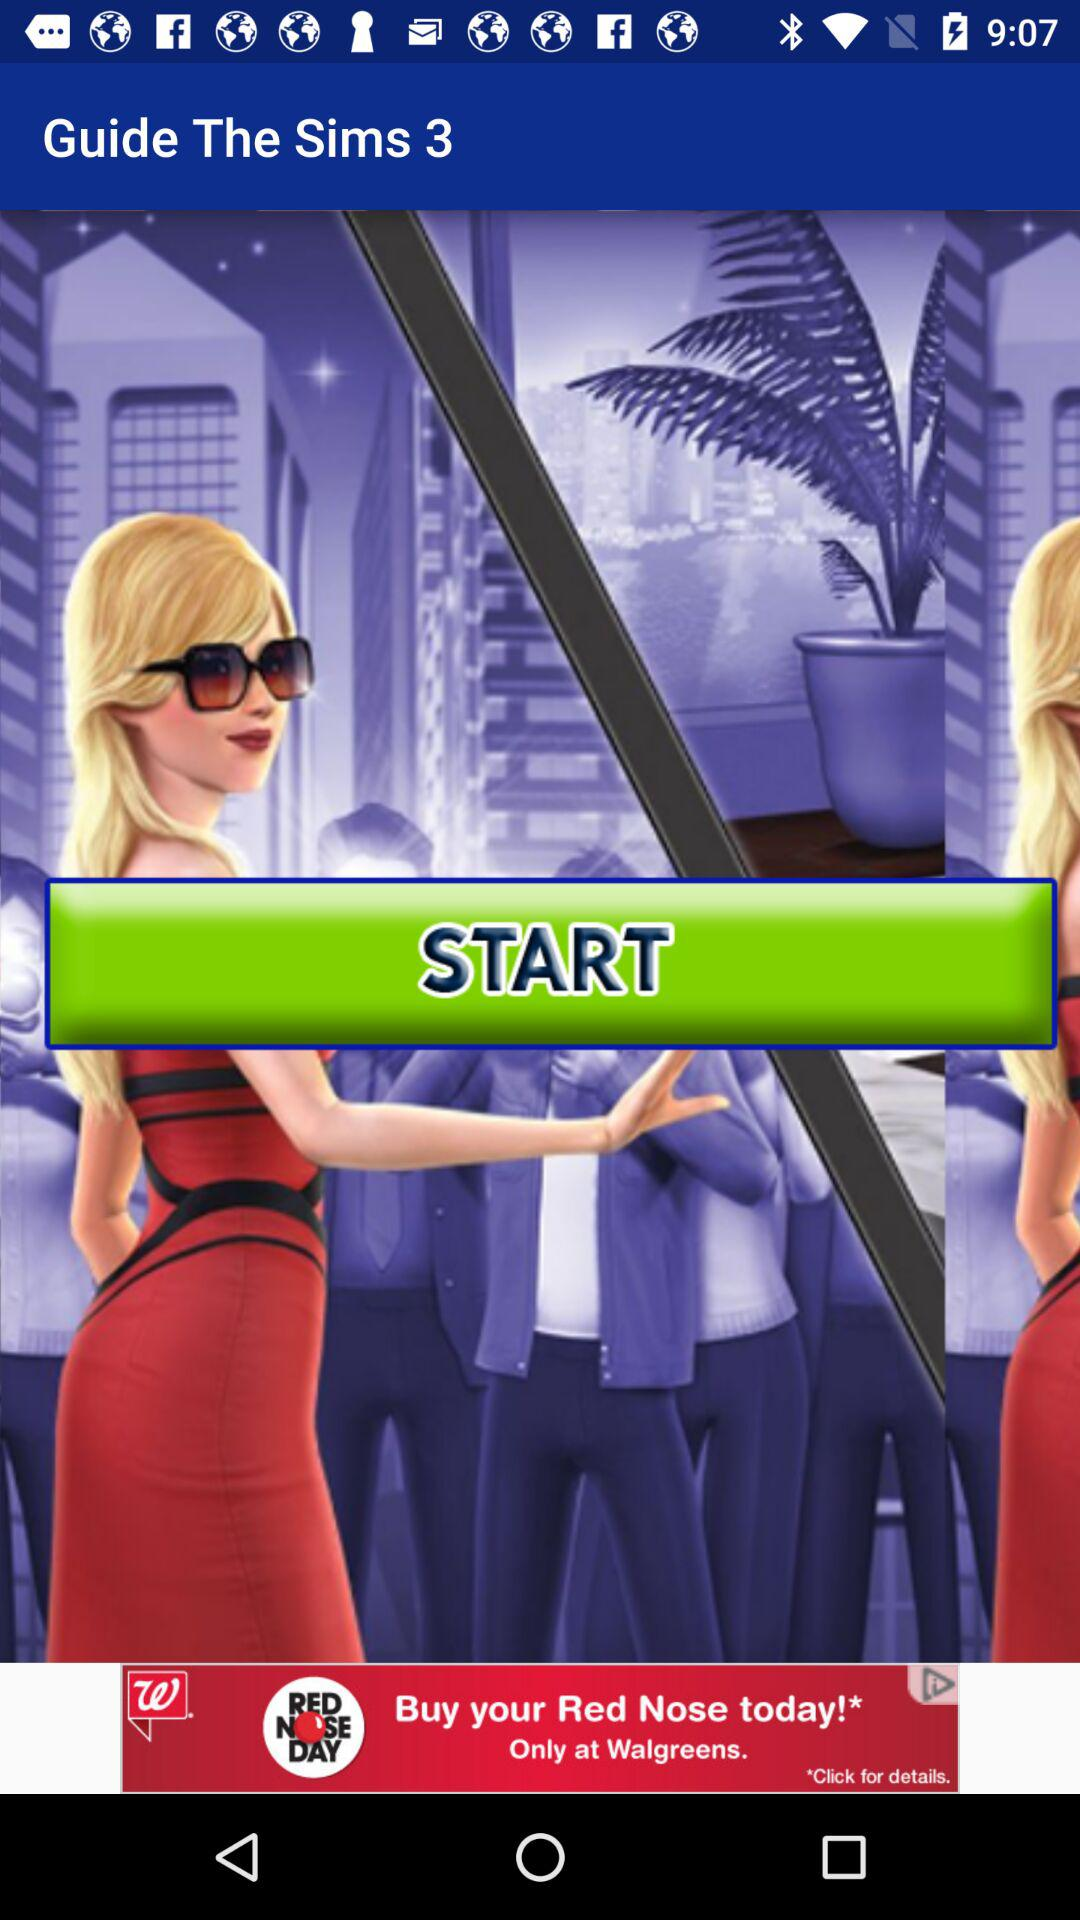What is the name of the application? The name of the application is "Guide The Sims 3". 